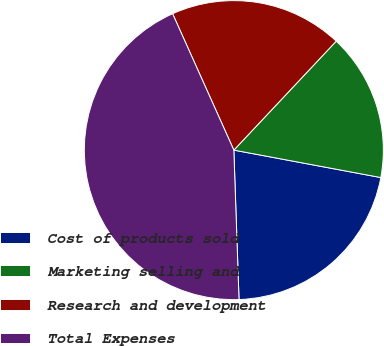Convert chart to OTSL. <chart><loc_0><loc_0><loc_500><loc_500><pie_chart><fcel>Cost of products sold<fcel>Marketing selling and<fcel>Research and development<fcel>Total Expenses<nl><fcel>21.51%<fcel>15.93%<fcel>18.72%<fcel>43.83%<nl></chart> 